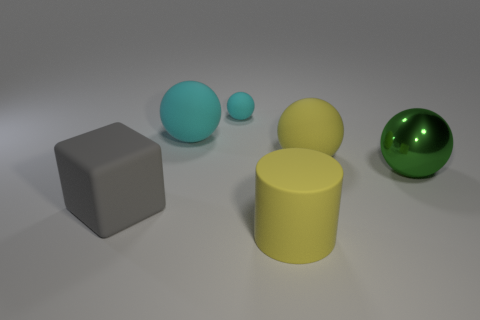What number of green metallic objects have the same size as the green metal ball?
Provide a short and direct response. 0. There is a gray rubber object in front of the small matte ball; is it the same shape as the large yellow thing that is in front of the large green metal sphere?
Ensure brevity in your answer.  No. What is the color of the matte object that is on the right side of the big yellow thing that is in front of the green thing?
Provide a succinct answer. Yellow. The large metallic thing that is the same shape as the tiny cyan object is what color?
Provide a succinct answer. Green. Is there any other thing that has the same material as the large green thing?
Keep it short and to the point. No. There is another yellow thing that is the same shape as the large metal object; what is its size?
Keep it short and to the point. Large. There is a big yellow object that is in front of the green ball; what is it made of?
Keep it short and to the point. Rubber. Is the number of tiny balls that are behind the tiny cyan object less than the number of large yellow rubber blocks?
Offer a very short reply. No. What is the shape of the yellow thing in front of the large metallic sphere that is behind the yellow cylinder?
Provide a short and direct response. Cylinder. What is the color of the big matte cylinder?
Your response must be concise. Yellow. 